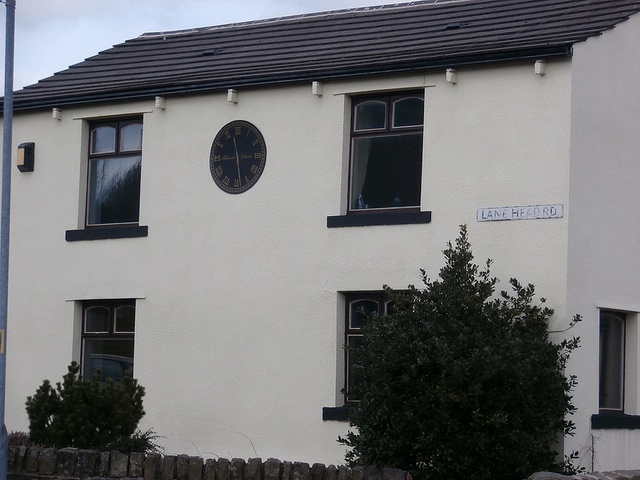Describe the objects in this image and their specific colors. I can see a clock in blue, black, gray, and darkgray tones in this image. 